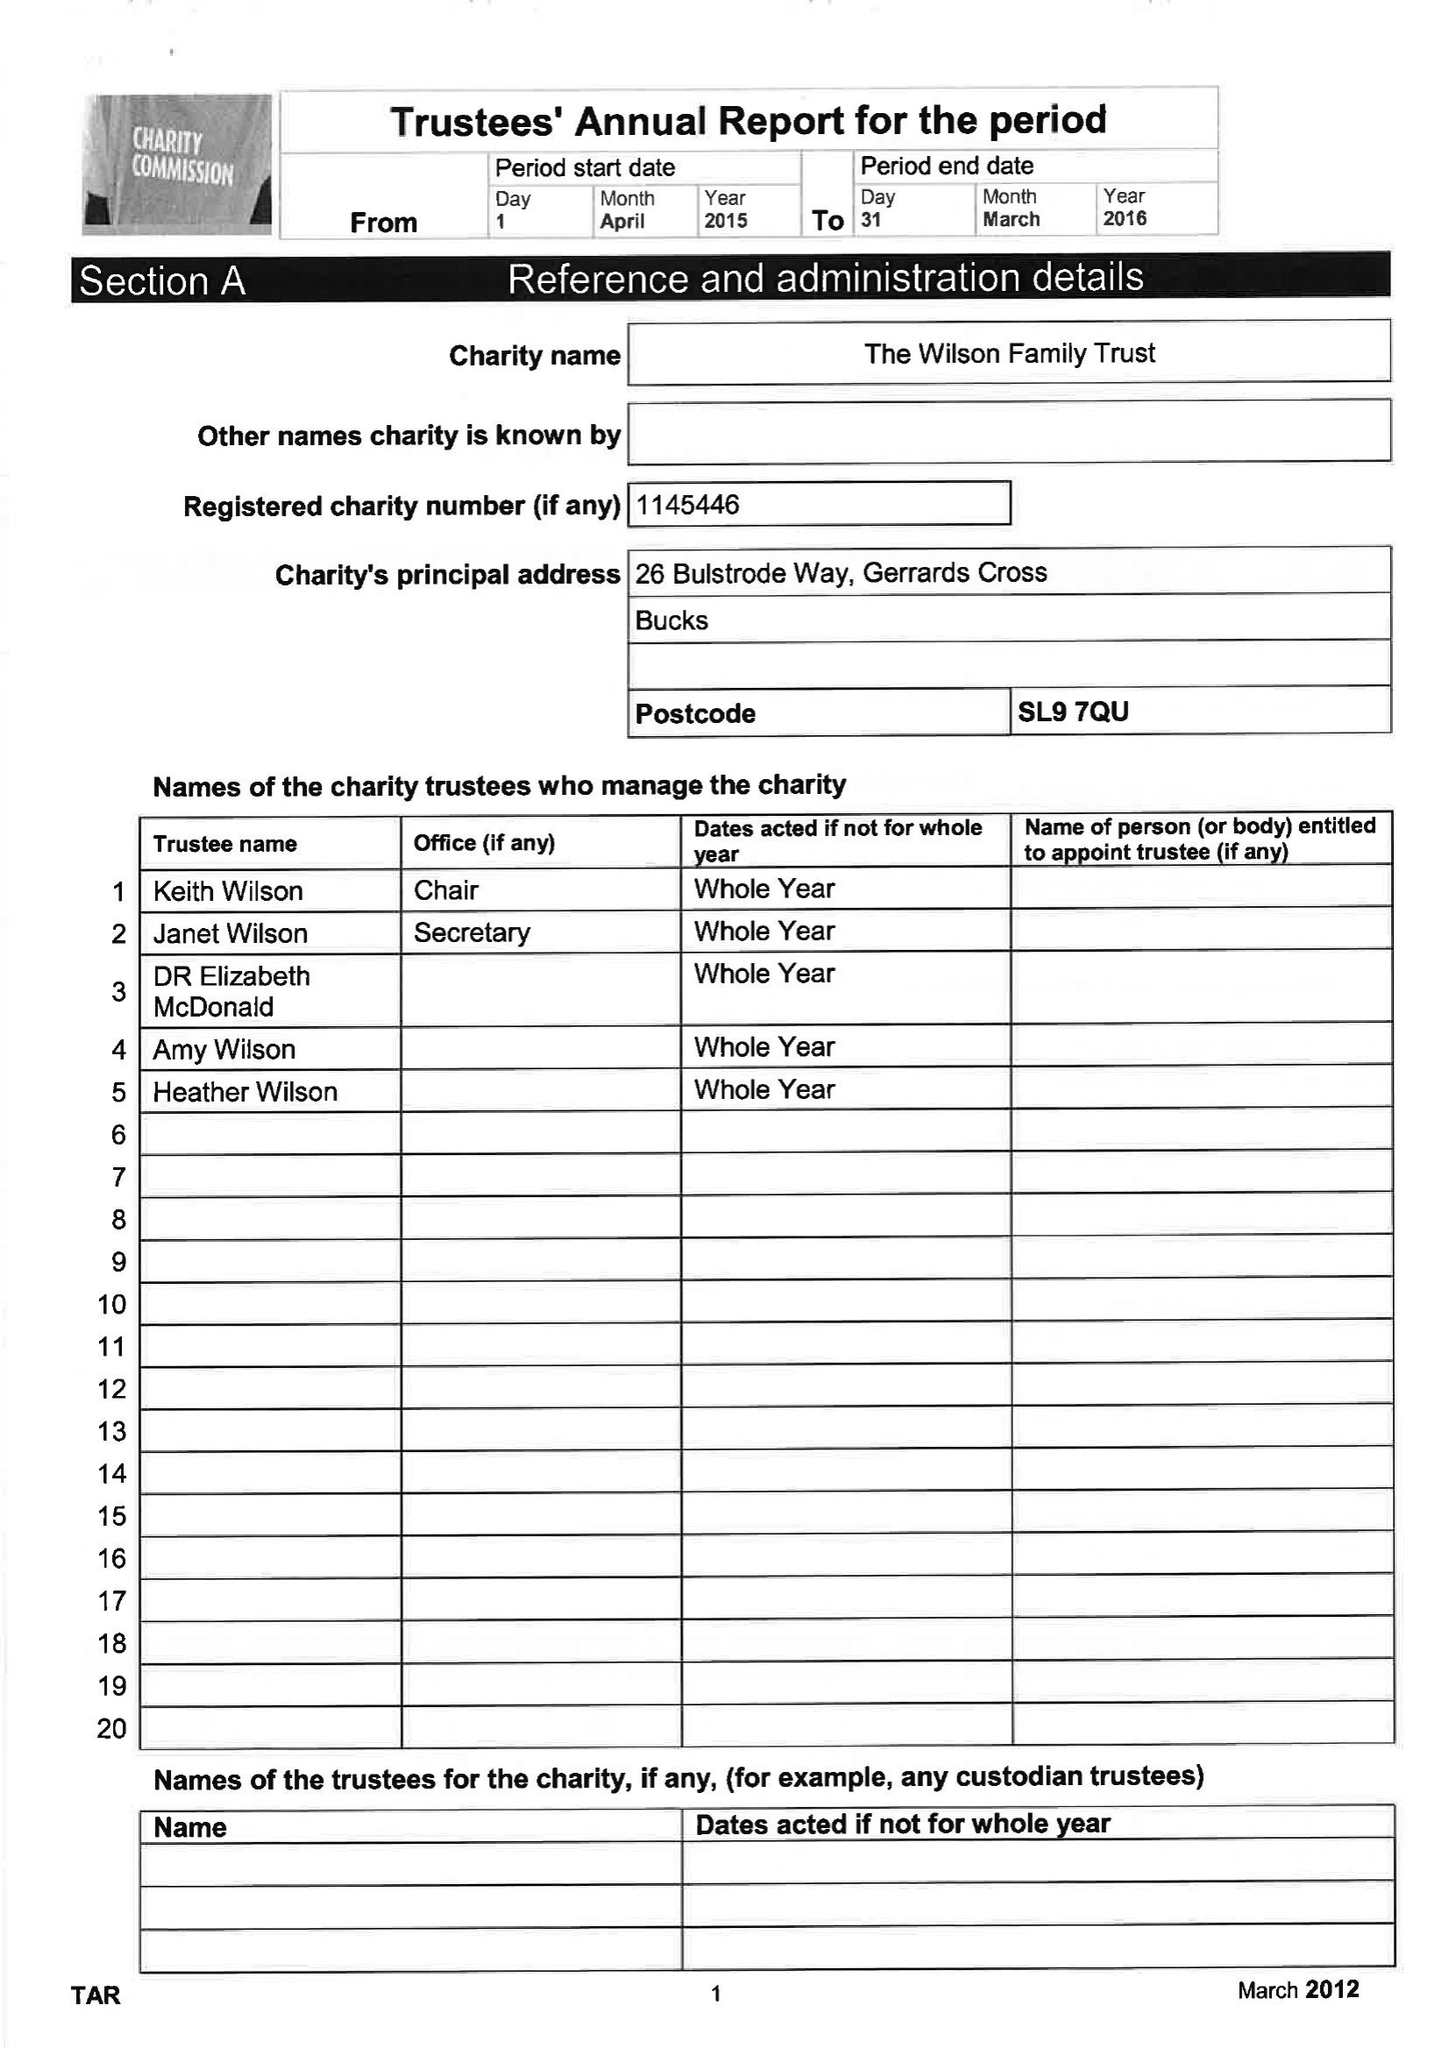What is the value for the address__post_town?
Answer the question using a single word or phrase. GERRARDS CROSS 